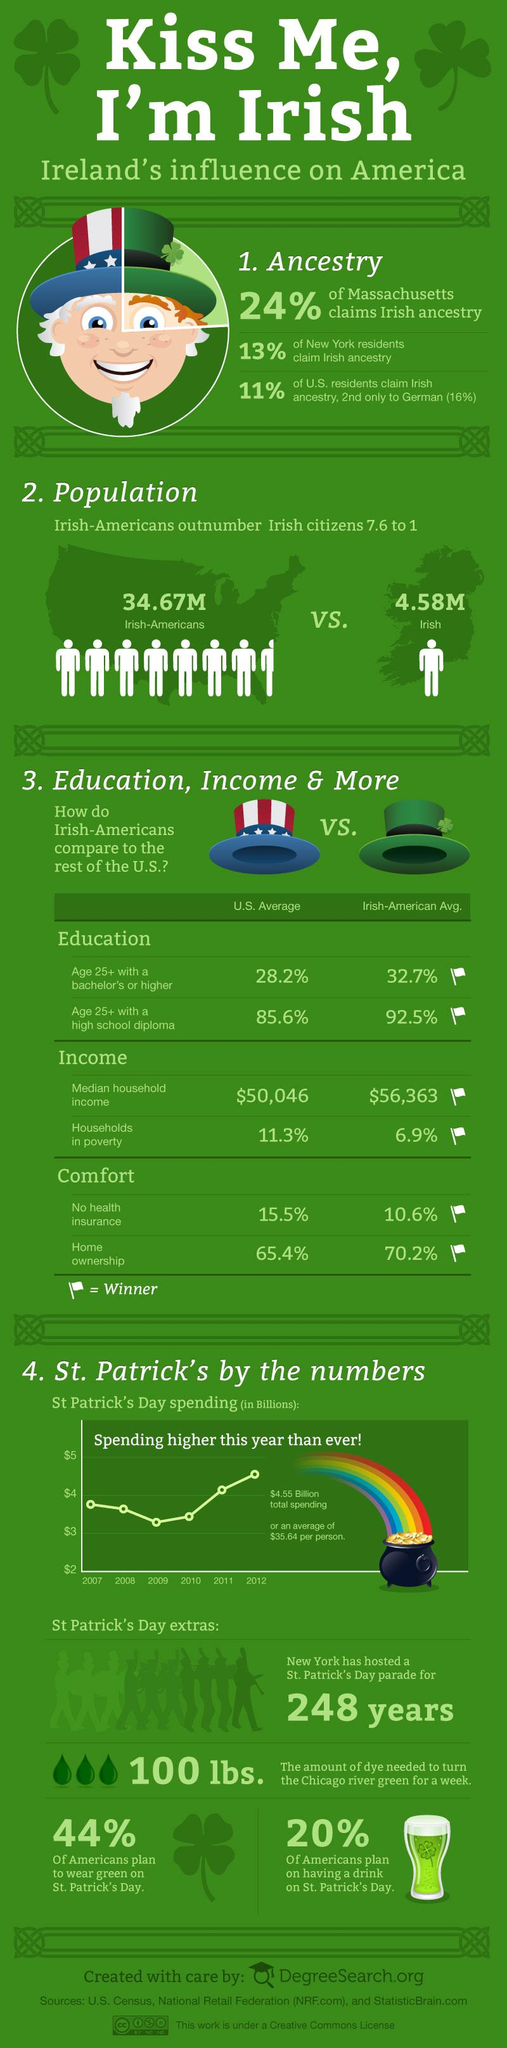Highlight a few significant elements in this photo. According to the data, 84% of German residents did not claim Irish ancestry. According to the data, 87% of New York residents did not claim Irish ancestry. According to a recent survey, 89% of US residents did not claim Irish ancestry. A large percentage of Americans, approximately 80%, do not plan on consuming alcohol on St. Patrick's Day. According to a survey, 56% of Americans do not have any plans to wear green on St. Patrick's Day, 